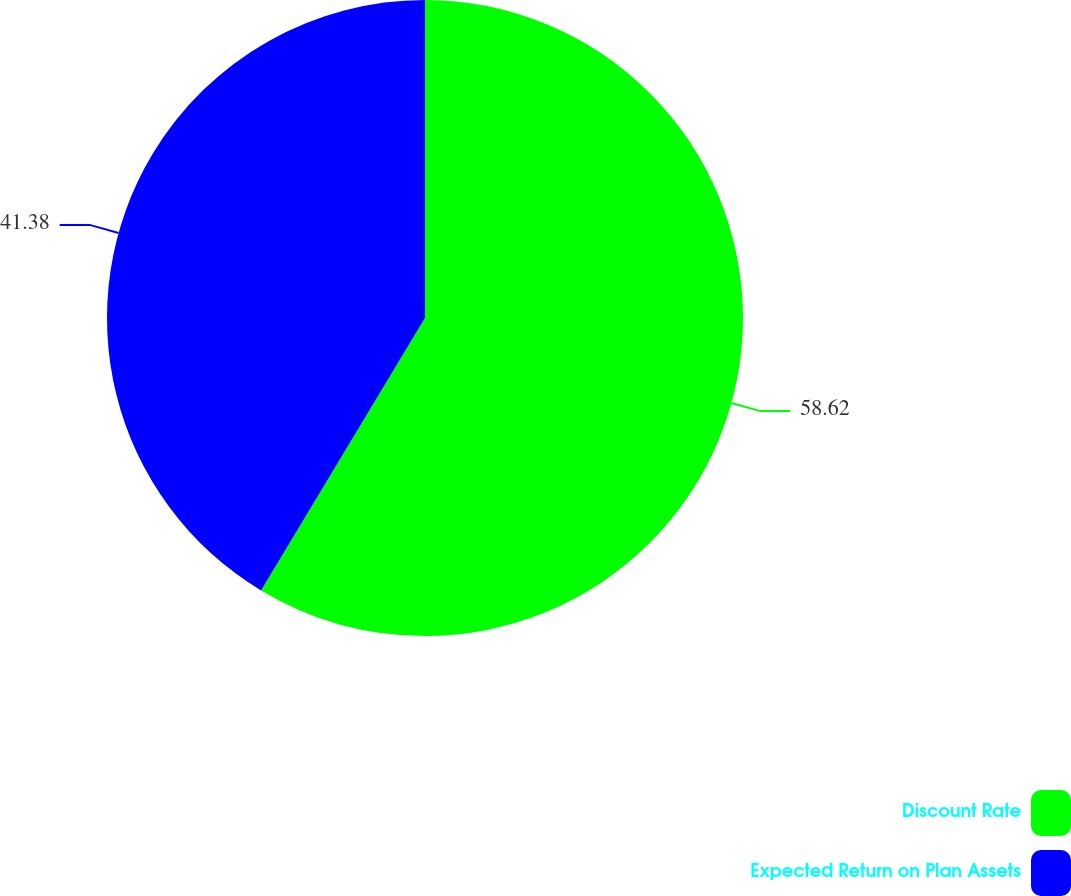Convert chart. <chart><loc_0><loc_0><loc_500><loc_500><pie_chart><fcel>Discount Rate<fcel>Expected Return on Plan Assets<nl><fcel>58.62%<fcel>41.38%<nl></chart> 